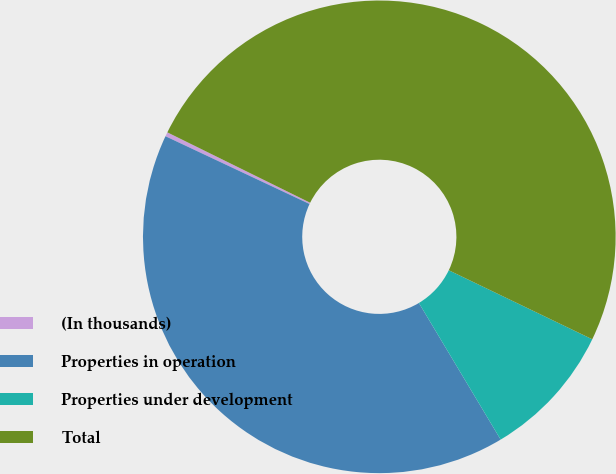<chart> <loc_0><loc_0><loc_500><loc_500><pie_chart><fcel>(In thousands)<fcel>Properties in operation<fcel>Properties under development<fcel>Total<nl><fcel>0.29%<fcel>40.58%<fcel>9.28%<fcel>49.85%<nl></chart> 